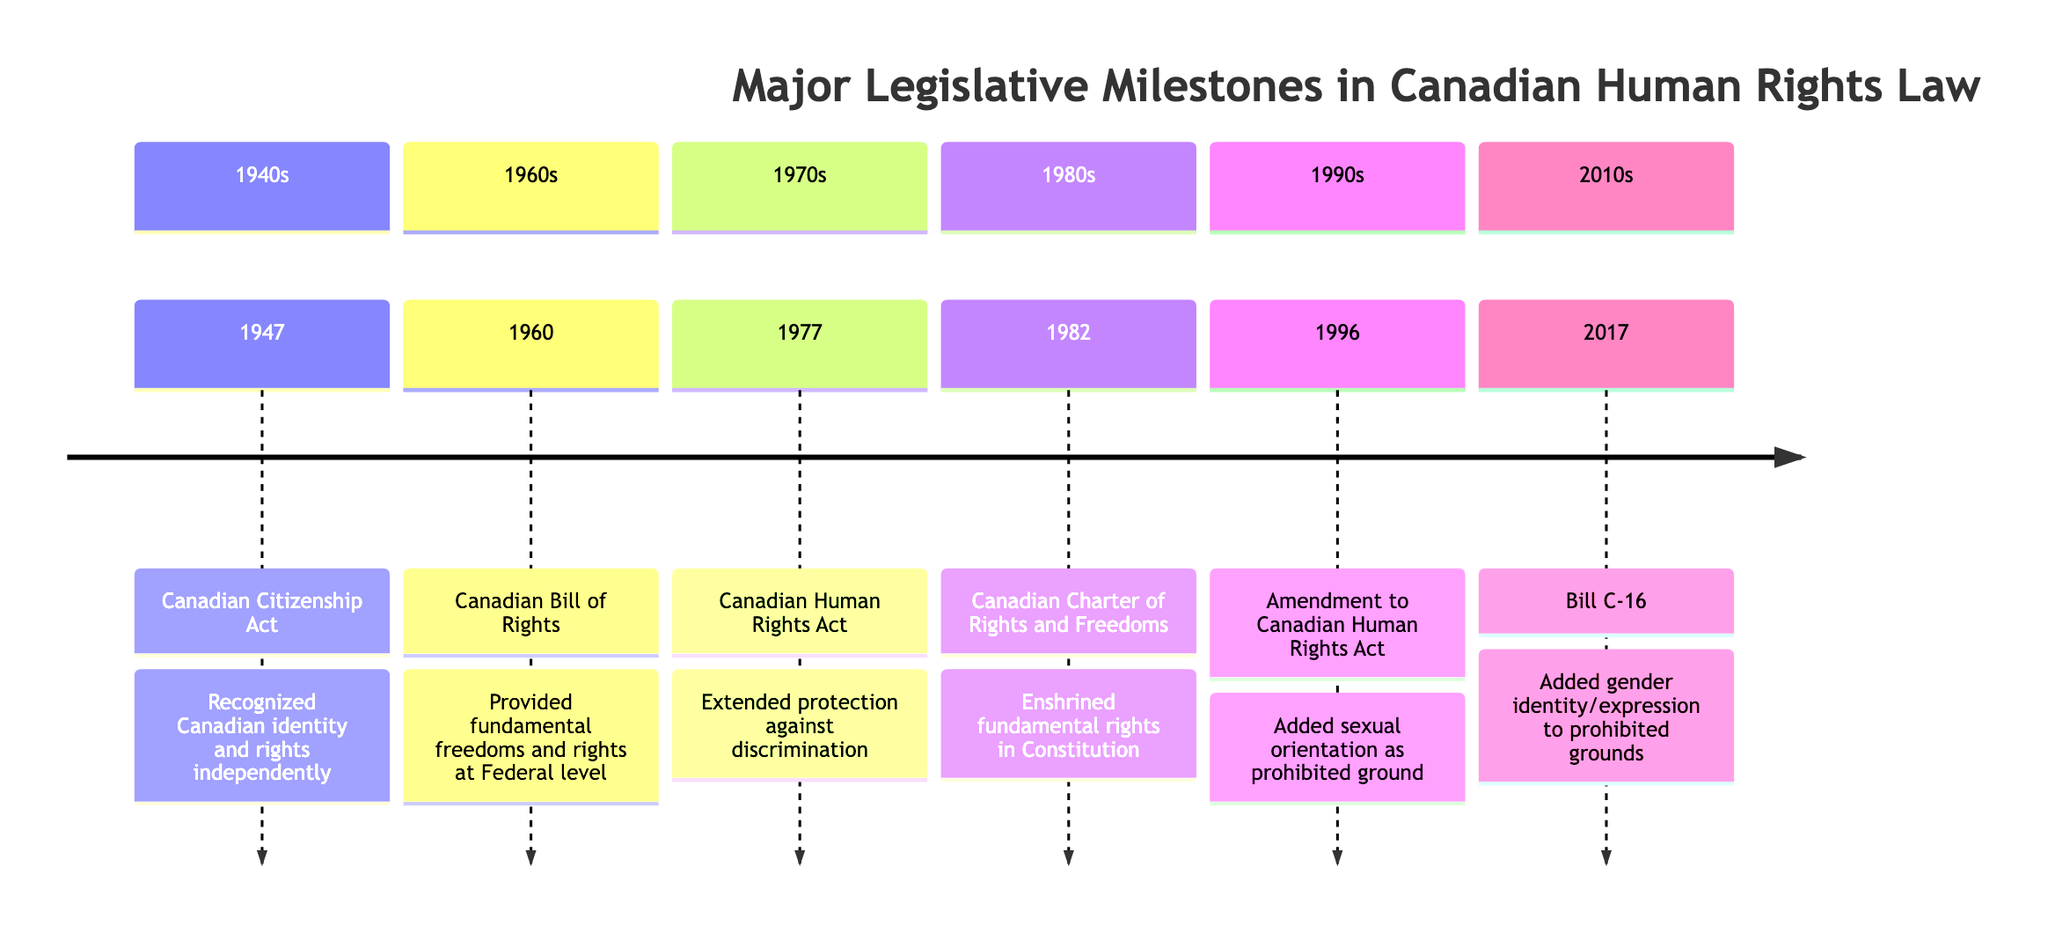What year was the Canadian Citizenship Act enacted? The diagram shows that the Canadian Citizenship Act occurred in 1947. You can find this information in the section labeled '1940s'.
Answer: 1947 What significant change occurred with the amendment to the Canadian Human Rights Act in 1996? The diagram indicates that in 1996, the amendment added sexual orientation as a prohibited ground of discrimination. This information is highlighted in the section labeled '1990s'.
Answer: Added sexual orientation How many major legislative milestones are listed in the timeline? By counting the events shown in each section of the timeline, there are six major legislative milestones: one in each of the 1940s, 1960s, 1970s, 1980s, 1990s, and 2010s sections.
Answer: 6 Which act was established in 1982? The diagram explicitly states that the Canadian Charter of Rights and Freedoms was enacted in 1982, which is located in the section labeled '1980s'.
Answer: Canadian Charter of Rights and Freedoms What was the purpose of Bill C-16 passed in 2017? According to the diagram, Bill C-16 aimed to add gender identity or expression to the prohibited grounds of discrimination, which is clearly stated in the section labeled '2010s'.
Answer: Added gender identity/expression What is the first event listed in the timeline? By reviewing the timeline from the beginning, the first event listed is the Canadian Citizenship Act in 1947, which is in the '1940s' section.
Answer: Canadian Citizenship Act How did the Canadian Charter of Rights and Freedoms strengthen Canadian human rights? The timeline explains that it enshrined fundamental freedoms and rights in the Constitution Act of 1982, establishing robust legal safeguards for human rights. This is highlighted in the section labeled '1980s'.
Answer: Enshrined fundamental freedoms and rights Which piece of legislation was enacted to protect against discrimination on multiple grounds, including sexual orientation and gender identity? The diagram shows that both the Canadian Human Rights Act and Bill C-16 addressed protections against discrimination on these grounds, occurring in 1977 and 2017, respectively.
Answer: Canadian Human Rights Act and Bill C-16 